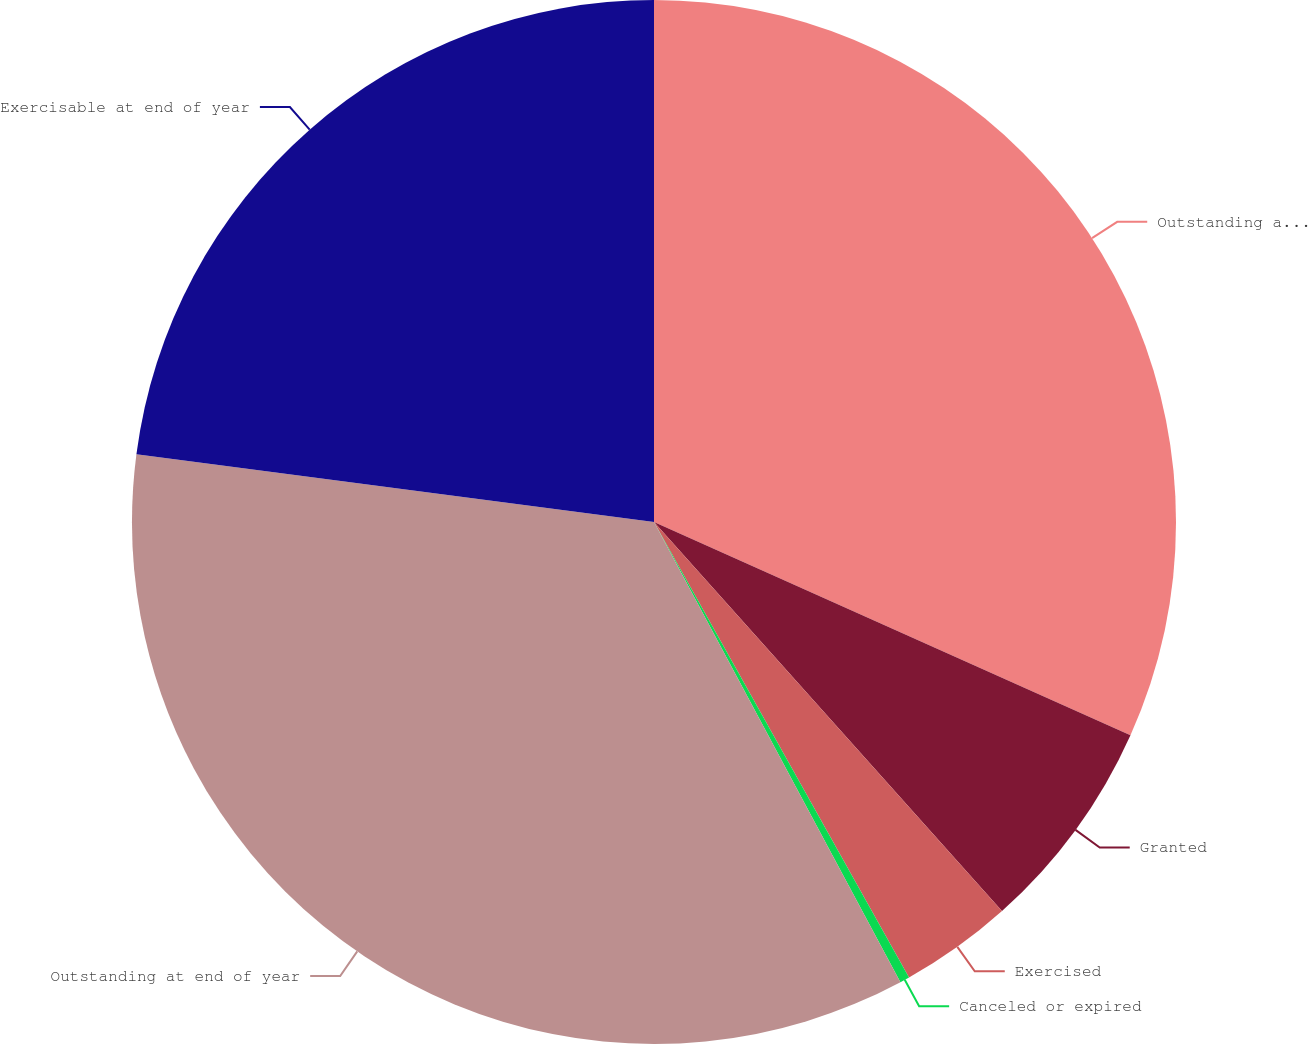Convert chart. <chart><loc_0><loc_0><loc_500><loc_500><pie_chart><fcel>Outstanding at beginning of<fcel>Granted<fcel>Exercised<fcel>Canceled or expired<fcel>Outstanding at end of year<fcel>Exercisable at end of year<nl><fcel>31.7%<fcel>6.69%<fcel>3.49%<fcel>0.3%<fcel>34.9%<fcel>22.93%<nl></chart> 